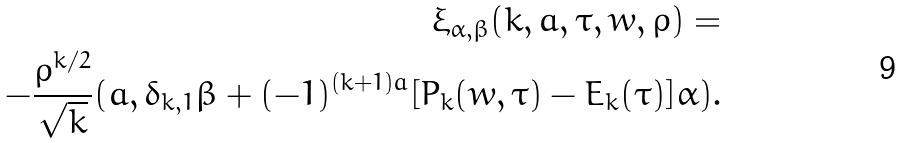<formula> <loc_0><loc_0><loc_500><loc_500>\xi _ { \alpha , \beta } ( k , a , \tau , w , \rho ) = \\ - \frac { \rho ^ { k / 2 } } { \sqrt { k } } ( a , \delta _ { k , 1 } \beta + ( - 1 ) ^ { ( k + 1 ) a } [ P _ { k } ( w , \tau ) - E _ { k } ( \tau ) ] \alpha ) .</formula> 